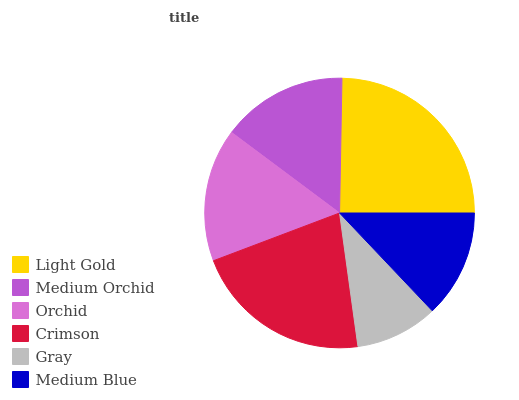Is Gray the minimum?
Answer yes or no. Yes. Is Light Gold the maximum?
Answer yes or no. Yes. Is Medium Orchid the minimum?
Answer yes or no. No. Is Medium Orchid the maximum?
Answer yes or no. No. Is Light Gold greater than Medium Orchid?
Answer yes or no. Yes. Is Medium Orchid less than Light Gold?
Answer yes or no. Yes. Is Medium Orchid greater than Light Gold?
Answer yes or no. No. Is Light Gold less than Medium Orchid?
Answer yes or no. No. Is Orchid the high median?
Answer yes or no. Yes. Is Medium Orchid the low median?
Answer yes or no. Yes. Is Crimson the high median?
Answer yes or no. No. Is Medium Blue the low median?
Answer yes or no. No. 